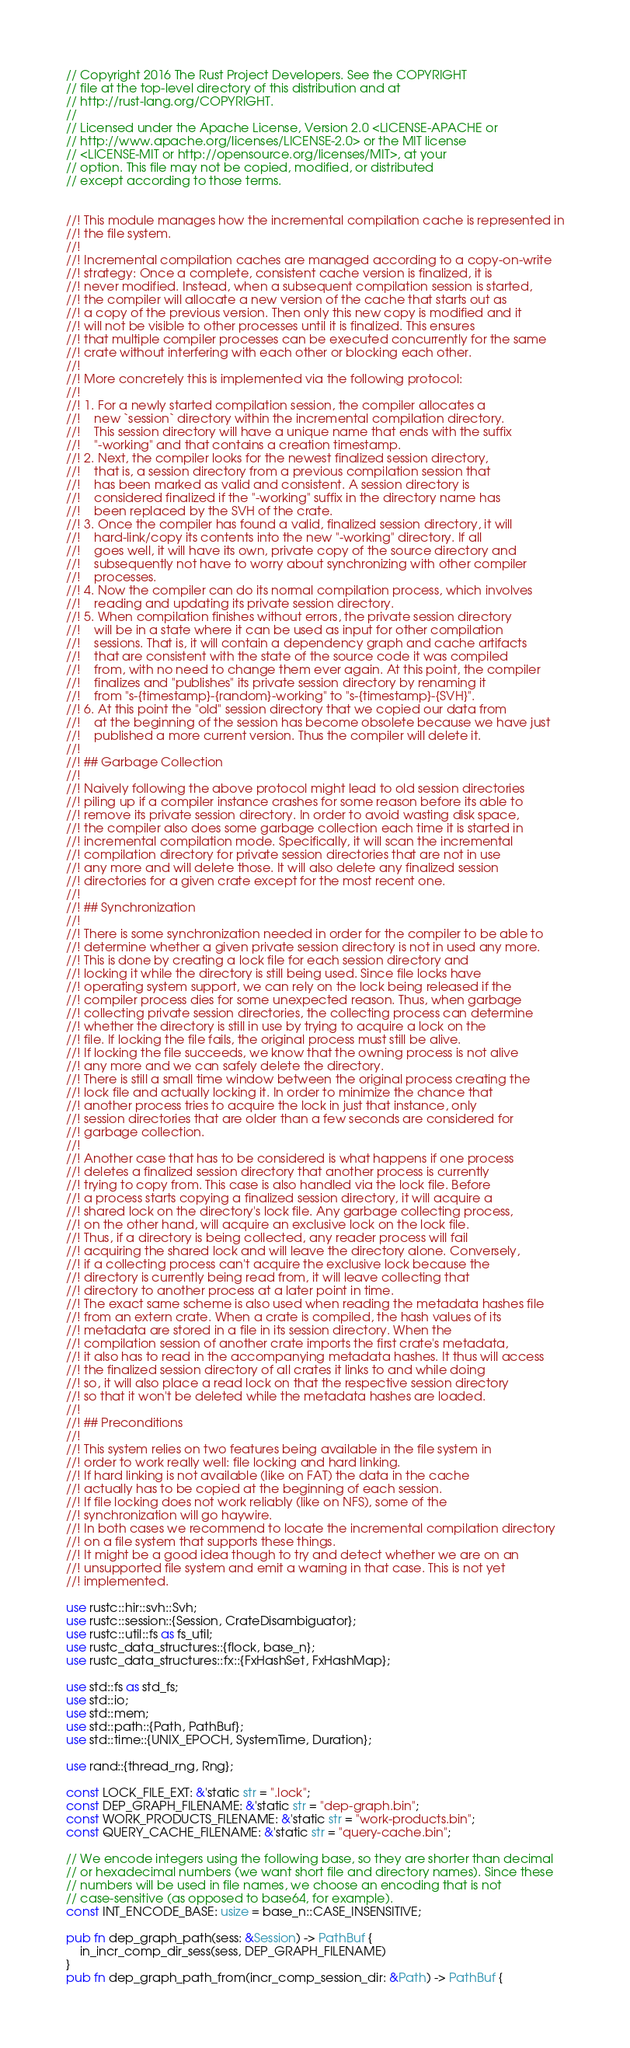<code> <loc_0><loc_0><loc_500><loc_500><_Rust_>// Copyright 2016 The Rust Project Developers. See the COPYRIGHT
// file at the top-level directory of this distribution and at
// http://rust-lang.org/COPYRIGHT.
//
// Licensed under the Apache License, Version 2.0 <LICENSE-APACHE or
// http://www.apache.org/licenses/LICENSE-2.0> or the MIT license
// <LICENSE-MIT or http://opensource.org/licenses/MIT>, at your
// option. This file may not be copied, modified, or distributed
// except according to those terms.


//! This module manages how the incremental compilation cache is represented in
//! the file system.
//!
//! Incremental compilation caches are managed according to a copy-on-write
//! strategy: Once a complete, consistent cache version is finalized, it is
//! never modified. Instead, when a subsequent compilation session is started,
//! the compiler will allocate a new version of the cache that starts out as
//! a copy of the previous version. Then only this new copy is modified and it
//! will not be visible to other processes until it is finalized. This ensures
//! that multiple compiler processes can be executed concurrently for the same
//! crate without interfering with each other or blocking each other.
//!
//! More concretely this is implemented via the following protocol:
//!
//! 1. For a newly started compilation session, the compiler allocates a
//!    new `session` directory within the incremental compilation directory.
//!    This session directory will have a unique name that ends with the suffix
//!    "-working" and that contains a creation timestamp.
//! 2. Next, the compiler looks for the newest finalized session directory,
//!    that is, a session directory from a previous compilation session that
//!    has been marked as valid and consistent. A session directory is
//!    considered finalized if the "-working" suffix in the directory name has
//!    been replaced by the SVH of the crate.
//! 3. Once the compiler has found a valid, finalized session directory, it will
//!    hard-link/copy its contents into the new "-working" directory. If all
//!    goes well, it will have its own, private copy of the source directory and
//!    subsequently not have to worry about synchronizing with other compiler
//!    processes.
//! 4. Now the compiler can do its normal compilation process, which involves
//!    reading and updating its private session directory.
//! 5. When compilation finishes without errors, the private session directory
//!    will be in a state where it can be used as input for other compilation
//!    sessions. That is, it will contain a dependency graph and cache artifacts
//!    that are consistent with the state of the source code it was compiled
//!    from, with no need to change them ever again. At this point, the compiler
//!    finalizes and "publishes" its private session directory by renaming it
//!    from "s-{timestamp}-{random}-working" to "s-{timestamp}-{SVH}".
//! 6. At this point the "old" session directory that we copied our data from
//!    at the beginning of the session has become obsolete because we have just
//!    published a more current version. Thus the compiler will delete it.
//!
//! ## Garbage Collection
//!
//! Naively following the above protocol might lead to old session directories
//! piling up if a compiler instance crashes for some reason before its able to
//! remove its private session directory. In order to avoid wasting disk space,
//! the compiler also does some garbage collection each time it is started in
//! incremental compilation mode. Specifically, it will scan the incremental
//! compilation directory for private session directories that are not in use
//! any more and will delete those. It will also delete any finalized session
//! directories for a given crate except for the most recent one.
//!
//! ## Synchronization
//!
//! There is some synchronization needed in order for the compiler to be able to
//! determine whether a given private session directory is not in used any more.
//! This is done by creating a lock file for each session directory and
//! locking it while the directory is still being used. Since file locks have
//! operating system support, we can rely on the lock being released if the
//! compiler process dies for some unexpected reason. Thus, when garbage
//! collecting private session directories, the collecting process can determine
//! whether the directory is still in use by trying to acquire a lock on the
//! file. If locking the file fails, the original process must still be alive.
//! If locking the file succeeds, we know that the owning process is not alive
//! any more and we can safely delete the directory.
//! There is still a small time window between the original process creating the
//! lock file and actually locking it. In order to minimize the chance that
//! another process tries to acquire the lock in just that instance, only
//! session directories that are older than a few seconds are considered for
//! garbage collection.
//!
//! Another case that has to be considered is what happens if one process
//! deletes a finalized session directory that another process is currently
//! trying to copy from. This case is also handled via the lock file. Before
//! a process starts copying a finalized session directory, it will acquire a
//! shared lock on the directory's lock file. Any garbage collecting process,
//! on the other hand, will acquire an exclusive lock on the lock file.
//! Thus, if a directory is being collected, any reader process will fail
//! acquiring the shared lock and will leave the directory alone. Conversely,
//! if a collecting process can't acquire the exclusive lock because the
//! directory is currently being read from, it will leave collecting that
//! directory to another process at a later point in time.
//! The exact same scheme is also used when reading the metadata hashes file
//! from an extern crate. When a crate is compiled, the hash values of its
//! metadata are stored in a file in its session directory. When the
//! compilation session of another crate imports the first crate's metadata,
//! it also has to read in the accompanying metadata hashes. It thus will access
//! the finalized session directory of all crates it links to and while doing
//! so, it will also place a read lock on that the respective session directory
//! so that it won't be deleted while the metadata hashes are loaded.
//!
//! ## Preconditions
//!
//! This system relies on two features being available in the file system in
//! order to work really well: file locking and hard linking.
//! If hard linking is not available (like on FAT) the data in the cache
//! actually has to be copied at the beginning of each session.
//! If file locking does not work reliably (like on NFS), some of the
//! synchronization will go haywire.
//! In both cases we recommend to locate the incremental compilation directory
//! on a file system that supports these things.
//! It might be a good idea though to try and detect whether we are on an
//! unsupported file system and emit a warning in that case. This is not yet
//! implemented.

use rustc::hir::svh::Svh;
use rustc::session::{Session, CrateDisambiguator};
use rustc::util::fs as fs_util;
use rustc_data_structures::{flock, base_n};
use rustc_data_structures::fx::{FxHashSet, FxHashMap};

use std::fs as std_fs;
use std::io;
use std::mem;
use std::path::{Path, PathBuf};
use std::time::{UNIX_EPOCH, SystemTime, Duration};

use rand::{thread_rng, Rng};

const LOCK_FILE_EXT: &'static str = ".lock";
const DEP_GRAPH_FILENAME: &'static str = "dep-graph.bin";
const WORK_PRODUCTS_FILENAME: &'static str = "work-products.bin";
const QUERY_CACHE_FILENAME: &'static str = "query-cache.bin";

// We encode integers using the following base, so they are shorter than decimal
// or hexadecimal numbers (we want short file and directory names). Since these
// numbers will be used in file names, we choose an encoding that is not
// case-sensitive (as opposed to base64, for example).
const INT_ENCODE_BASE: usize = base_n::CASE_INSENSITIVE;

pub fn dep_graph_path(sess: &Session) -> PathBuf {
    in_incr_comp_dir_sess(sess, DEP_GRAPH_FILENAME)
}
pub fn dep_graph_path_from(incr_comp_session_dir: &Path) -> PathBuf {</code> 